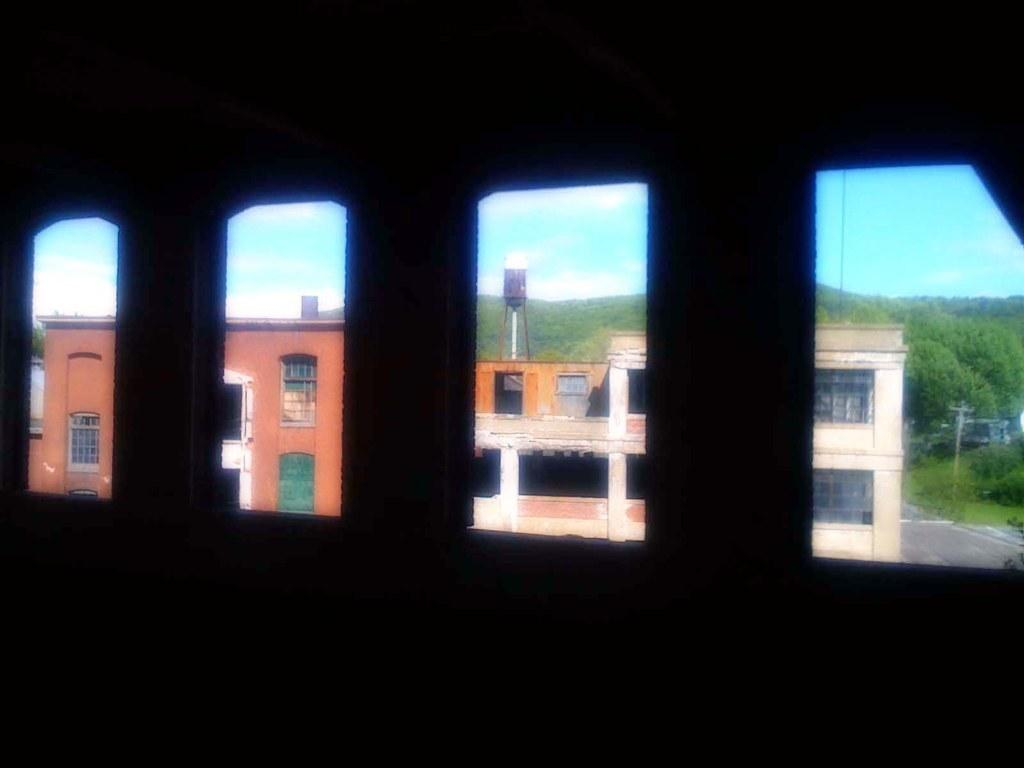What can be seen through the windows on the building in the image? Through the windows, buildings, trees, and the sky are visible. Can you describe the view from the windows? The view from the windows includes buildings, trees, and the sky. What type of map can be seen on the windowsill in the image? There is no map present in the image. What time of day does the image appear to be set in, considering the visibility of the sky? The time of day cannot be determined from the visibility of the sky alone, as the sky can be visible at various times of the day. 